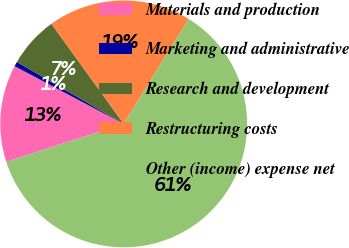Convert chart to OTSL. <chart><loc_0><loc_0><loc_500><loc_500><pie_chart><fcel>Materials and production<fcel>Marketing and administrative<fcel>Research and development<fcel>Restructuring costs<fcel>Other (income) expense net<nl><fcel>12.73%<fcel>0.62%<fcel>6.68%<fcel>18.79%<fcel>61.17%<nl></chart> 